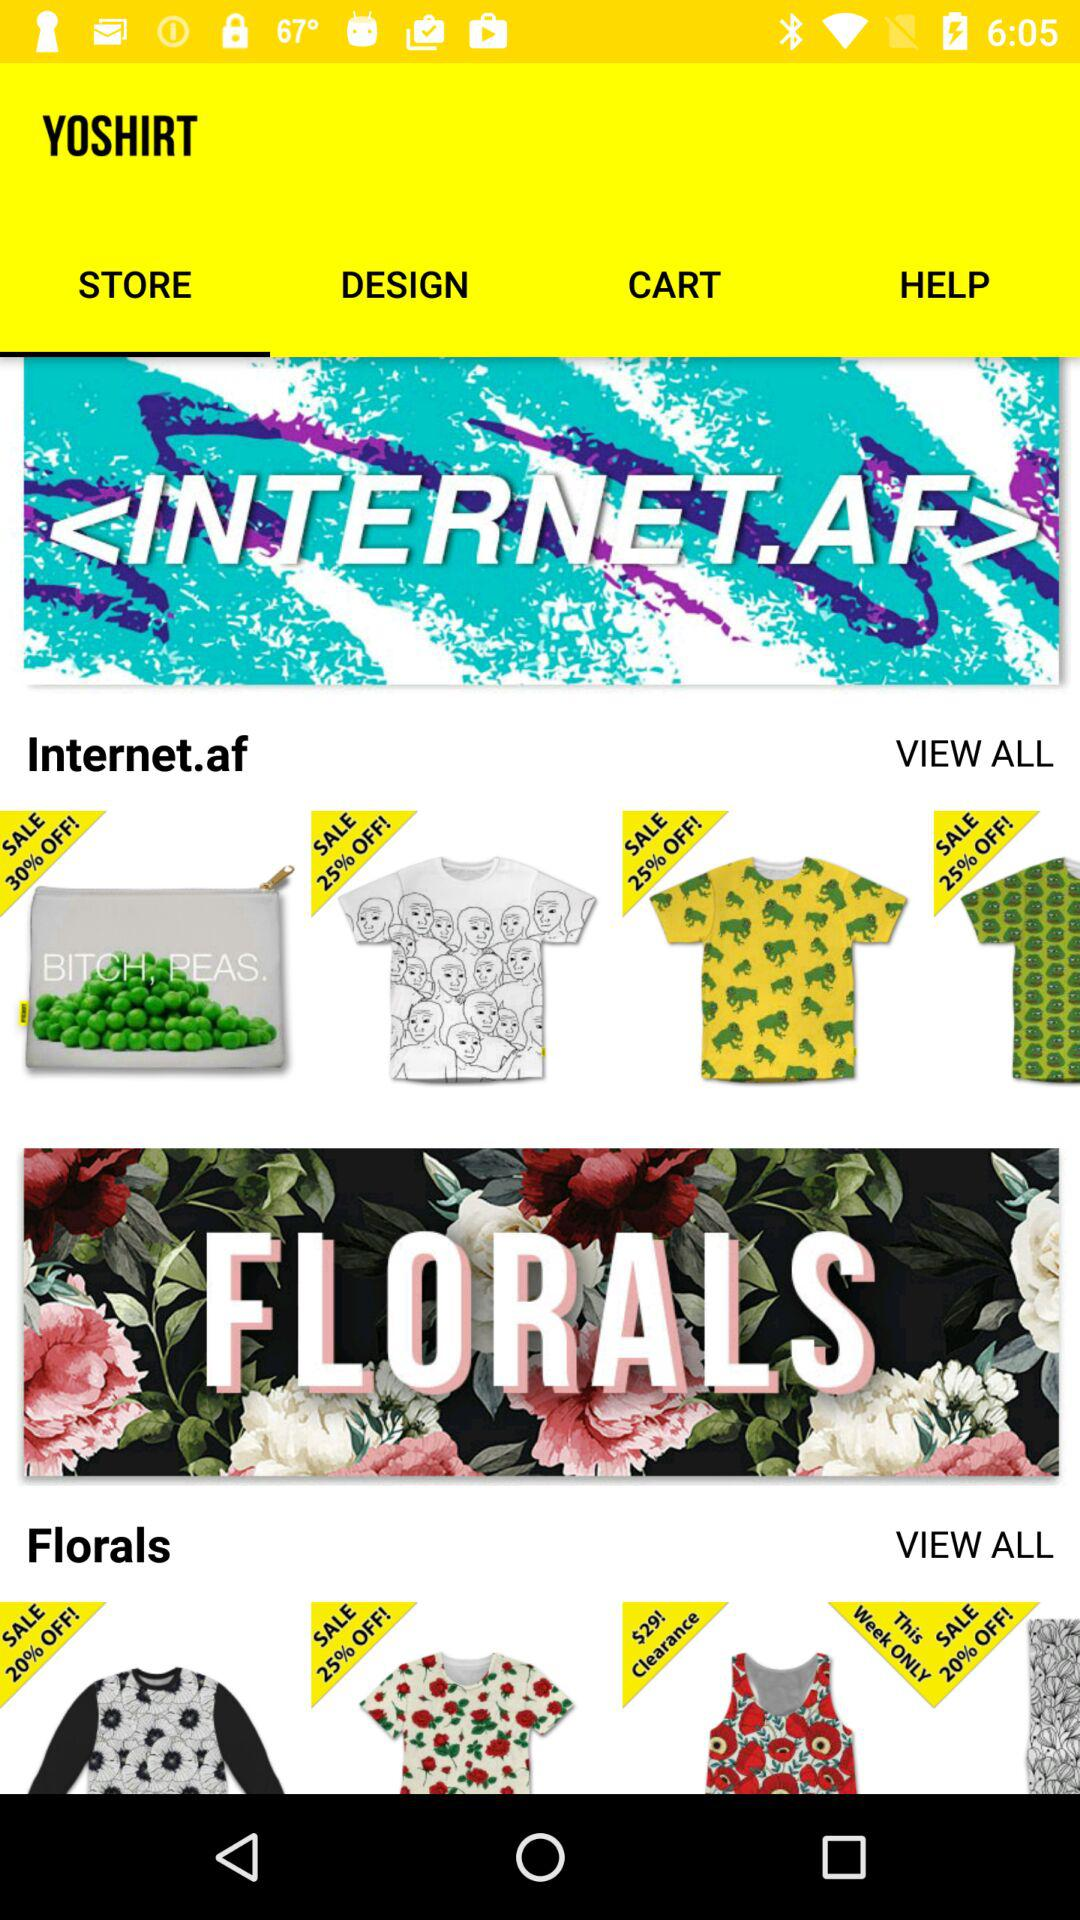Which tab has been selected? The selected tab is "STORE". 